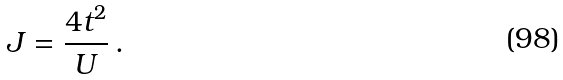<formula> <loc_0><loc_0><loc_500><loc_500>J = \frac { 4 t ^ { 2 } } { U } \, .</formula> 